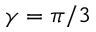<formula> <loc_0><loc_0><loc_500><loc_500>\gamma = \pi / 3</formula> 